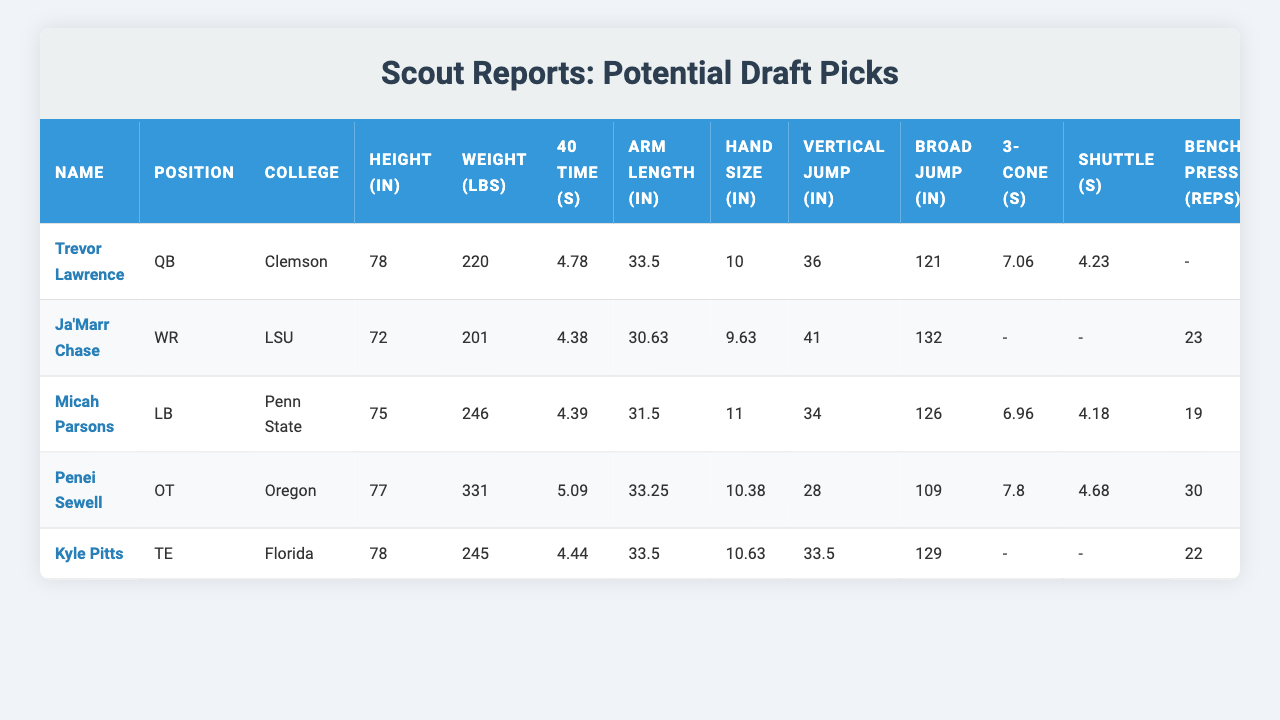What is the height of Trevor Lawrence? Trevor Lawrence's height is given as 78 inches in the table.
Answer: 78 inches Which player has the highest vertical jump? The player with the highest vertical jump is Ja'Marr Chase at 41 inches.
Answer: Ja'Marr Chase What is Micah Parsons' weight? According to the table, Micah Parsons weighs 246 pounds.
Answer: 246 pounds Is Kyle Pitts heavier than Penei Sewell? Kyle Pitts weighs 245 pounds and Penei Sewell weighs 331 pounds. Since 245 is less than 331, Kyle Pitts is not heavier than Penei Sewell.
Answer: No What is the average 40-yard dash time of all players listed? The 40 times are 4.78, 4.38, 4.39, 5.09, and 4.44. Adding these gives 24.08, then dividing by 5 gives an average of 4.816.
Answer: 4.816 seconds Who has the longest arm length among the players? The longest arm length is 33.5 inches shared by Trevor Lawrence and Kyle Pitts.
Answer: Trevor Lawrence and Kyle Pitts Which player performed the bench press and how many reps? Ja'Marr Chase, Micah Parsons, Penei Sewell, and Kyle Pitts performed the bench press with 23, 19, 30, and 22 reps, respectively.
Answer: Ja'Marr Chase (23 reps) How does Micah Parsons’ 40-yard dash time compare to Penei Sewell's? Micah Parsons has a 40-time of 4.39 seconds, while Penei Sewell has a 40-time of 5.09 seconds. Since 4.39 is less than 5.09, Micah Parsons is faster.
Answer: Micah Parsons is faster Count the number of players weighing over 250 pounds. Penei Sewell is the only player weighing 331 pounds, which is over 250.
Answer: 1 player What is the difference in hand size between Micah Parsons and Ja'Marr Chase? Micah Parsons has a hand size of 11 inches and Ja'Marr Chase has a hand size of 9.63 inches. The difference is 11 - 9.63 = 1.37 inches.
Answer: 1.37 inches 